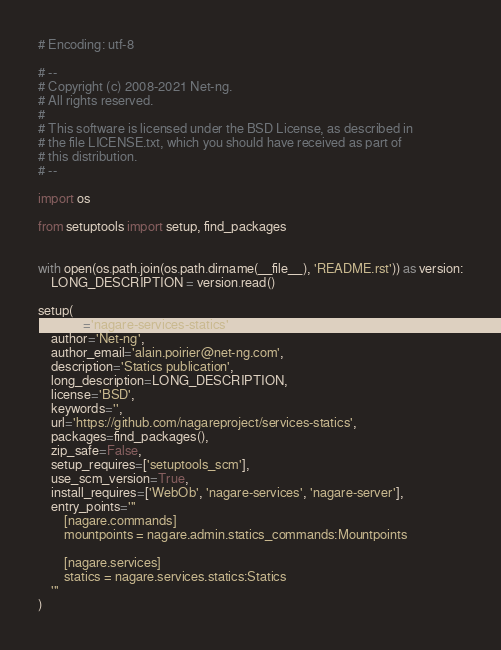<code> <loc_0><loc_0><loc_500><loc_500><_Python_># Encoding: utf-8

# --
# Copyright (c) 2008-2021 Net-ng.
# All rights reserved.
#
# This software is licensed under the BSD License, as described in
# the file LICENSE.txt, which you should have received as part of
# this distribution.
# --

import os

from setuptools import setup, find_packages


with open(os.path.join(os.path.dirname(__file__), 'README.rst')) as version:
    LONG_DESCRIPTION = version.read()

setup(
    name='nagare-services-statics',
    author='Net-ng',
    author_email='alain.poirier@net-ng.com',
    description='Statics publication',
    long_description=LONG_DESCRIPTION,
    license='BSD',
    keywords='',
    url='https://github.com/nagareproject/services-statics',
    packages=find_packages(),
    zip_safe=False,
    setup_requires=['setuptools_scm'],
    use_scm_version=True,
    install_requires=['WebOb', 'nagare-services', 'nagare-server'],
    entry_points='''
        [nagare.commands]
        mountpoints = nagare.admin.statics_commands:Mountpoints

        [nagare.services]
        statics = nagare.services.statics:Statics
    '''
)
</code> 